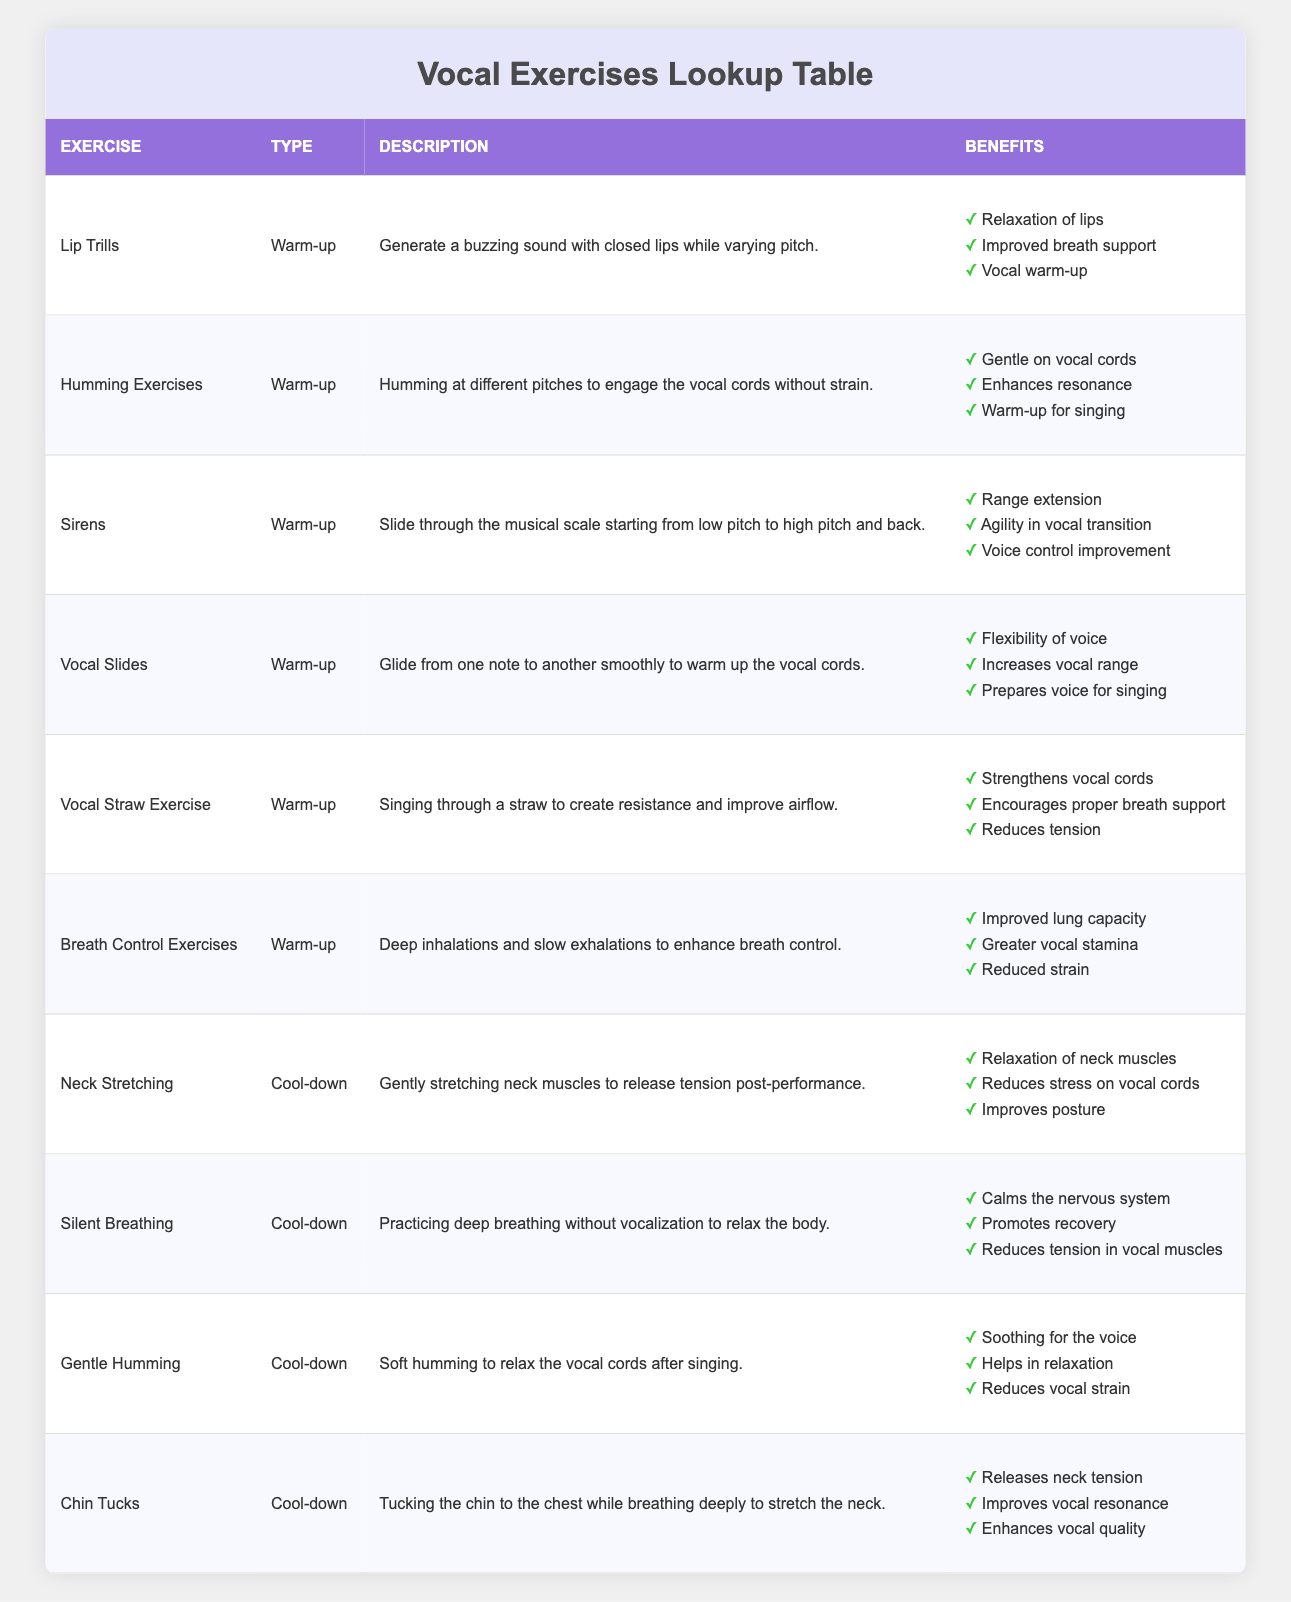What are the types of vocal exercises listed in the table? There are two types of vocal exercises listed: Warm-up and Cool-down. These are categorized based on their purpose in a singer's routine.
Answer: Warm-up and Cool-down Which exercise helps in reducing vocal strain? The exercise "Gentle Humming" is specifically mentioned for reducing vocal strain as it is soothing for the voice.
Answer: Gentle Humming What are the benefits of the "Vocal Straw Exercise"? The benefits include strengthening vocal cords, encouraging proper breath support, and reducing tension. These benefits are derived directly from the table's specified list for this exercise.
Answer: Strengthens vocal cords, encourages proper breath support, reduces tension How many benefits does the "Neck Stretching" exercise have? The "Neck Stretching" exercise has three specified benefits listed in the table, which are relaxation of neck muscles, reduction of stress on vocal cords, and improvement in posture.
Answer: Three benefits Does "Humming Exercises" qualify as a warm-up? Yes, "Humming Exercises" is classified as a warm-up in the table, meaning it is intended to prepare the voice for singing.
Answer: Yes Which exercises mentioned can improve vocal quality? Both "Chin Tucks" (which improves vocal resonance) and "Gentle Humming" (which helps in relaxation) can contribute to better vocal quality according to the table.
Answer: Chin Tucks, Gentle Humming What is the primary activity involved in the "Sirens" exercise? The primary activity in the "Sirens" exercise involves sliding through the musical scale from a low pitch to a high pitch and back, which helps in range extension and agility.
Answer: Sliding through the musical scale Which vocal exercise helps with breath control? The "Breath Control Exercises" specifically mention deep inhalations and slow exhalations to enhance breath control, making it the answer.
Answer: Breath Control Exercises How many exercises are categorized under warm-up? There are six exercises categorized under warm-up in the table: Lip Trills, Humming Exercises, Sirens, Vocal Slides, Vocal Straw Exercise, and Breath Control Exercises.
Answer: Six exercises 